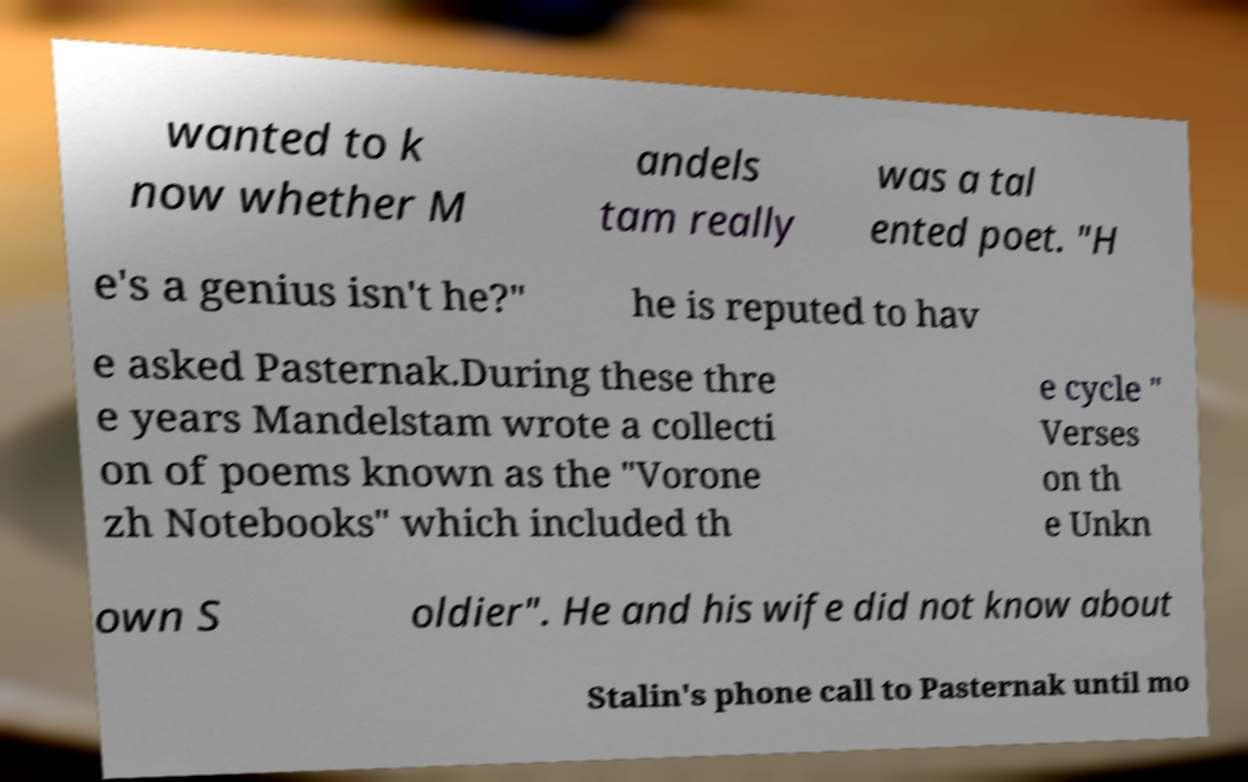I need the written content from this picture converted into text. Can you do that? wanted to k now whether M andels tam really was a tal ented poet. "H e's a genius isn't he?" he is reputed to hav e asked Pasternak.During these thre e years Mandelstam wrote a collecti on of poems known as the "Vorone zh Notebooks" which included th e cycle " Verses on th e Unkn own S oldier". He and his wife did not know about Stalin's phone call to Pasternak until mo 